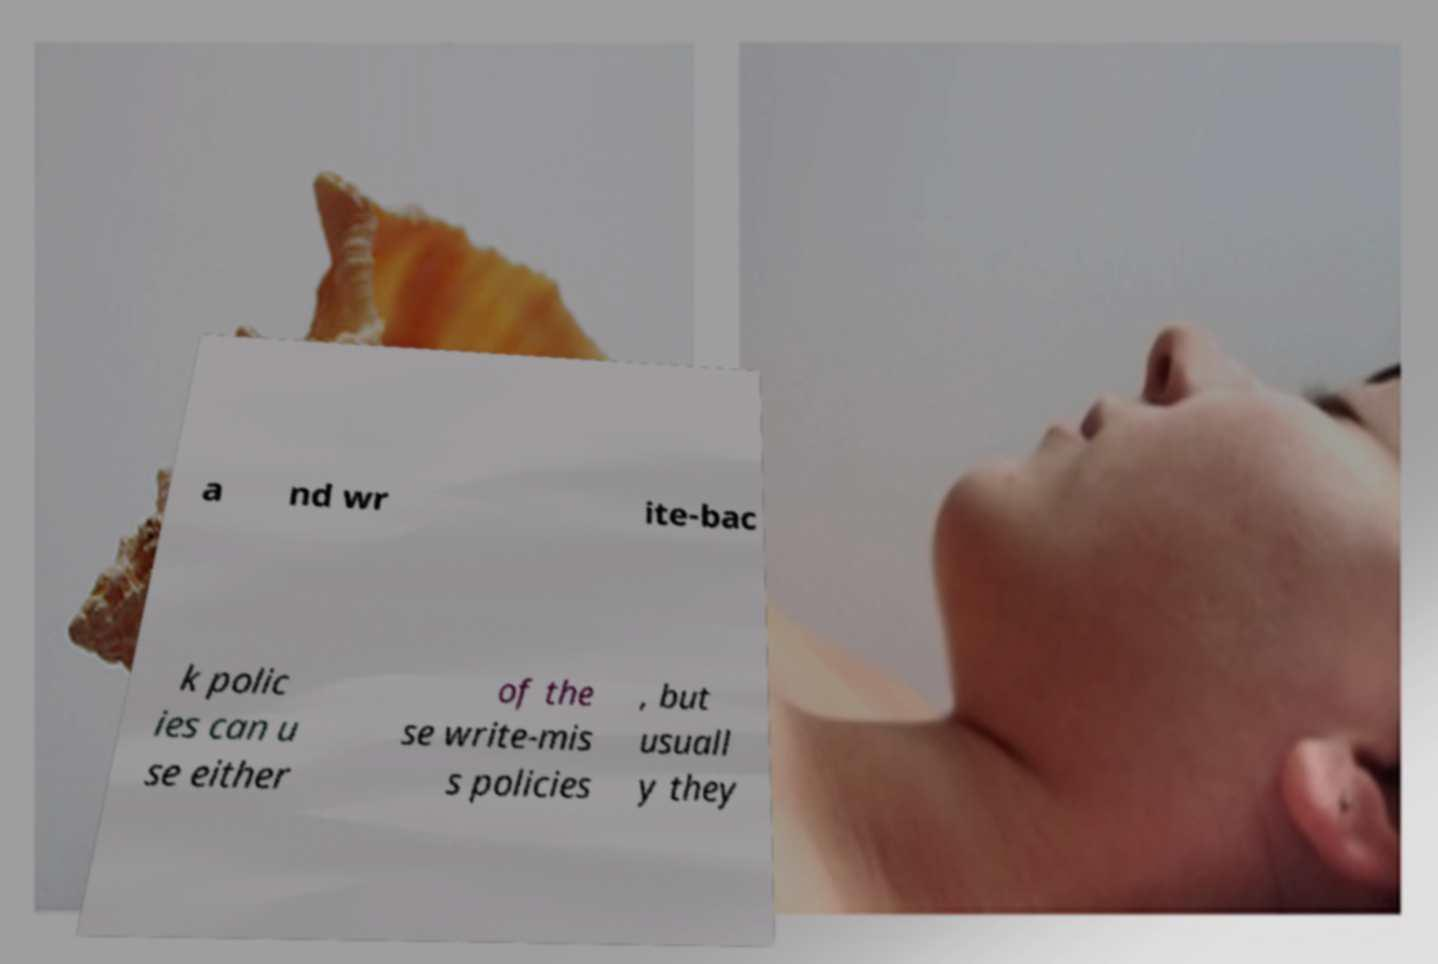Please identify and transcribe the text found in this image. a nd wr ite-bac k polic ies can u se either of the se write-mis s policies , but usuall y they 